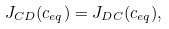<formula> <loc_0><loc_0><loc_500><loc_500>J _ { C D } ( c _ { e q } ) = J _ { D C } ( c _ { e q } ) ,</formula> 